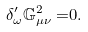<formula> <loc_0><loc_0><loc_500><loc_500>\delta _ { \omega } ^ { \prime } \mathbb { G } _ { \mu \nu } ^ { 2 } = & 0 .</formula> 